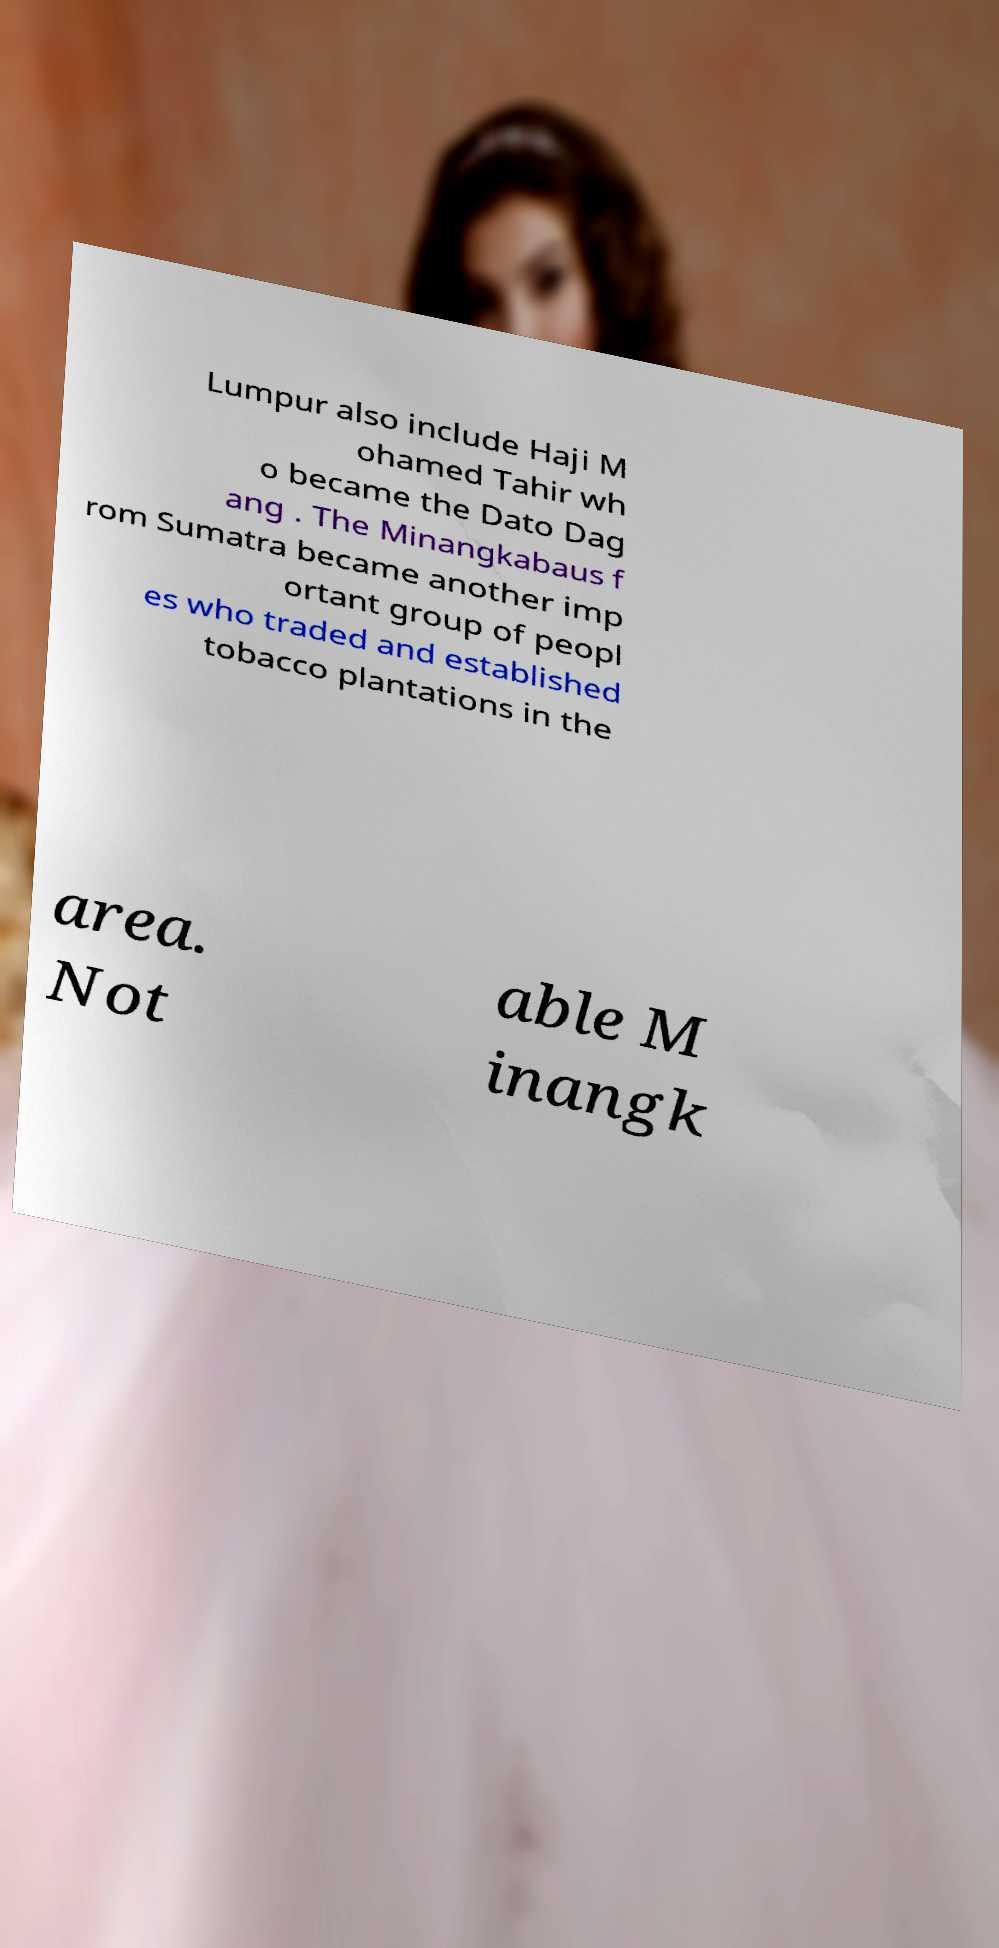Please read and relay the text visible in this image. What does it say? Lumpur also include Haji M ohamed Tahir wh o became the Dato Dag ang . The Minangkabaus f rom Sumatra became another imp ortant group of peopl es who traded and established tobacco plantations in the area. Not able M inangk 